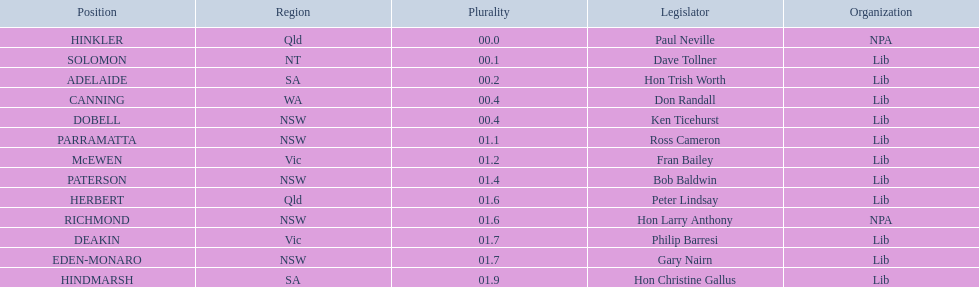Who is listed before don randall? Hon Trish Worth. 